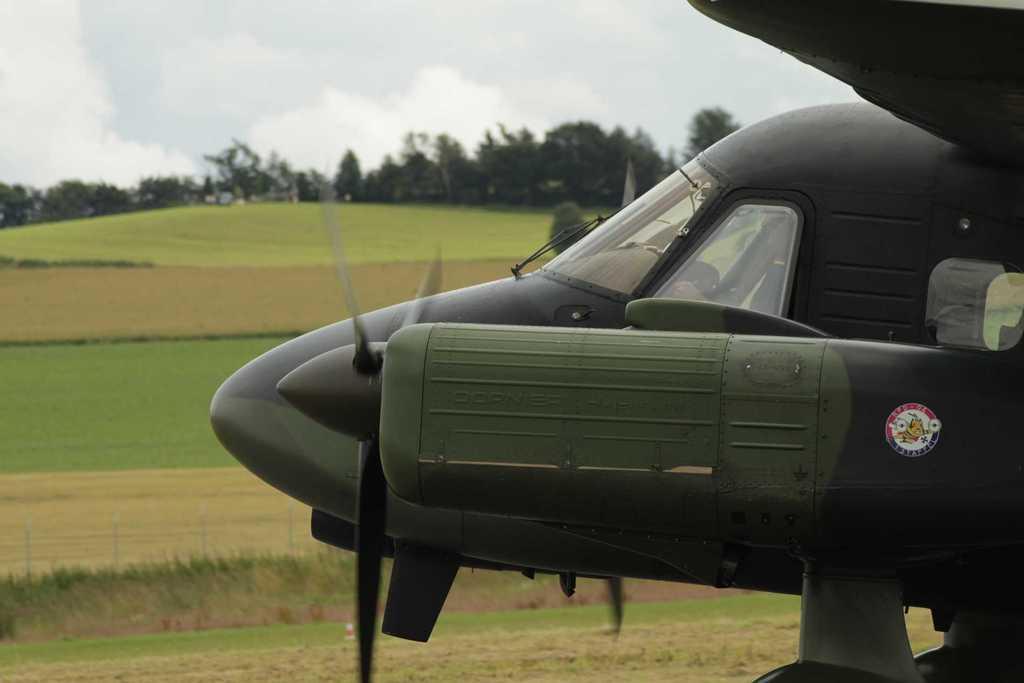Could you give a brief overview of what you see in this image? In this picture we can see a plane on the ground. In the background we can see mountain, farm land and trees. At the top we can see sky and clouds. In the bottom left corner we can see the fencing. 